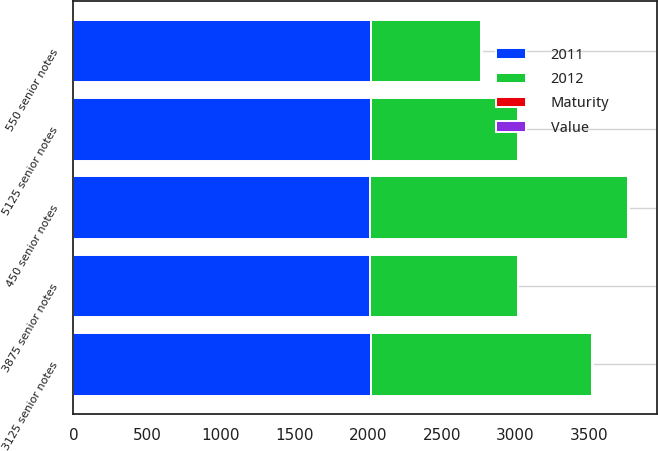Convert chart to OTSL. <chart><loc_0><loc_0><loc_500><loc_500><stacked_bar_chart><ecel><fcel>450 senior notes<fcel>3875 senior notes<fcel>550 senior notes<fcel>5125 senior notes<fcel>3125 senior notes<nl><fcel>2012<fcel>1750<fcel>1000<fcel>750<fcel>1000<fcel>1500<nl><fcel>2011<fcel>2013<fcel>2014<fcel>2018<fcel>2019<fcel>2021<nl><fcel>Value<fcel>2.51<fcel>1.14<fcel>2.71<fcel>2.2<fcel>1.28<nl><fcel>Maturity<fcel>2.39<fcel>0.99<fcel>2.53<fcel>2.04<fcel>0.52<nl></chart> 